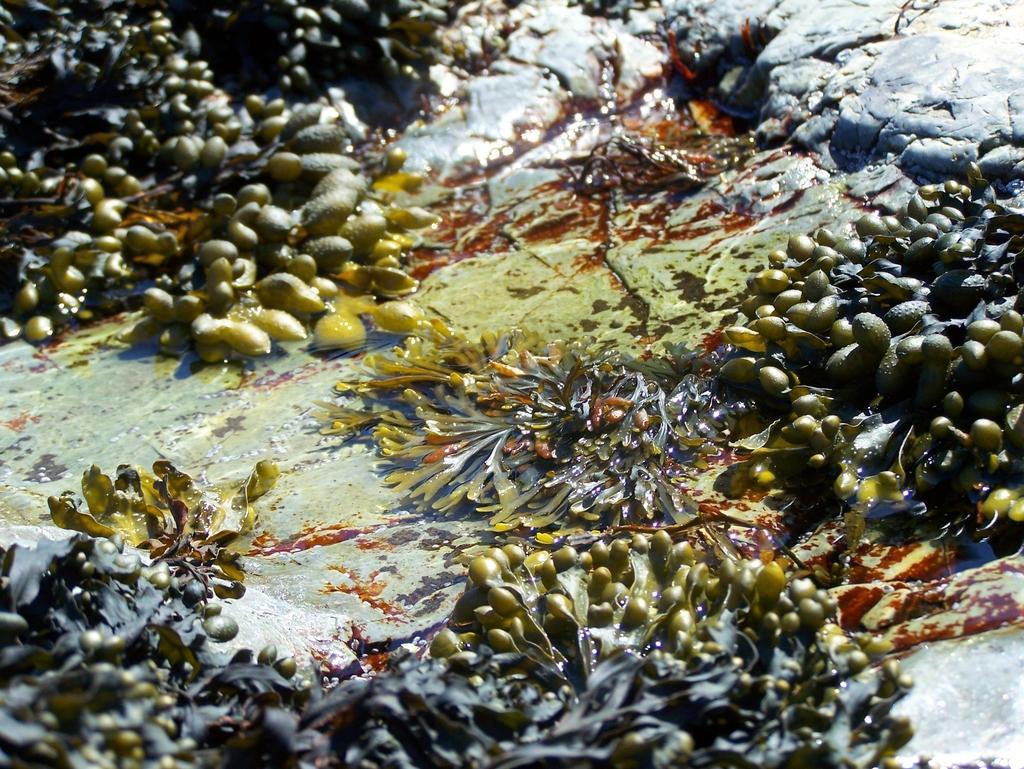How would you summarize this image in a sentence or two? In this image I can see some plants in the water which are in green and grey color. To the side of the plants I can see the rock which is in ash color. 